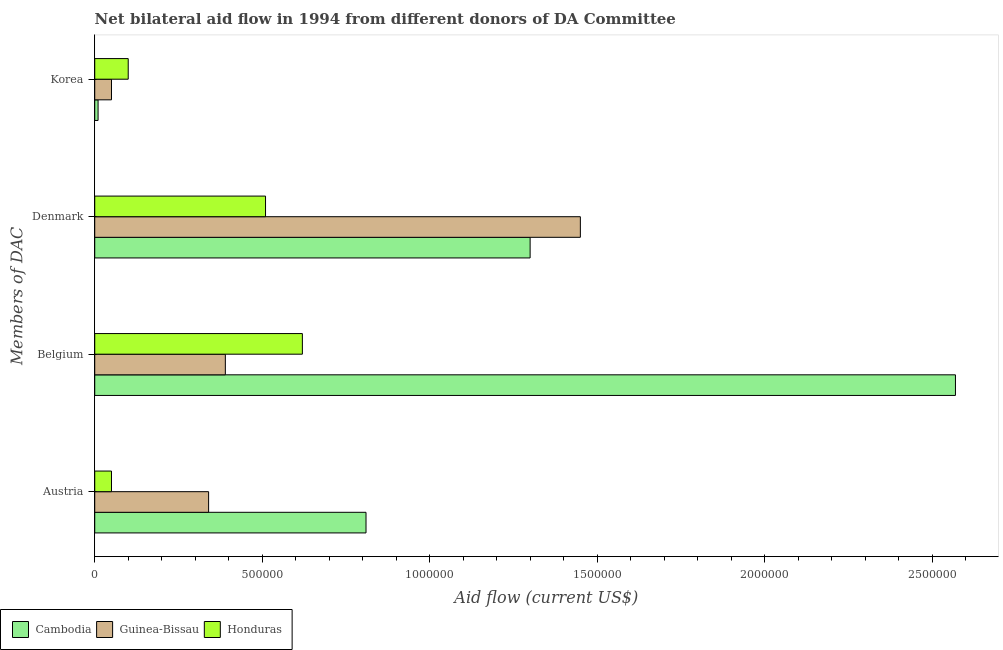How many different coloured bars are there?
Provide a succinct answer. 3. Are the number of bars per tick equal to the number of legend labels?
Provide a succinct answer. Yes. How many bars are there on the 1st tick from the top?
Make the answer very short. 3. What is the amount of aid given by belgium in Cambodia?
Provide a short and direct response. 2.57e+06. Across all countries, what is the maximum amount of aid given by belgium?
Your answer should be compact. 2.57e+06. Across all countries, what is the minimum amount of aid given by austria?
Offer a terse response. 5.00e+04. In which country was the amount of aid given by denmark maximum?
Your response must be concise. Guinea-Bissau. In which country was the amount of aid given by denmark minimum?
Your answer should be very brief. Honduras. What is the total amount of aid given by austria in the graph?
Offer a terse response. 1.20e+06. What is the difference between the amount of aid given by denmark in Cambodia and that in Honduras?
Your answer should be very brief. 7.90e+05. What is the difference between the amount of aid given by korea in Cambodia and the amount of aid given by austria in Guinea-Bissau?
Offer a very short reply. -3.30e+05. What is the average amount of aid given by korea per country?
Make the answer very short. 5.33e+04. What is the difference between the amount of aid given by belgium and amount of aid given by austria in Honduras?
Your response must be concise. 5.70e+05. In how many countries, is the amount of aid given by denmark greater than 1300000 US$?
Offer a very short reply. 1. What is the difference between the highest and the lowest amount of aid given by austria?
Keep it short and to the point. 7.60e+05. In how many countries, is the amount of aid given by korea greater than the average amount of aid given by korea taken over all countries?
Offer a terse response. 1. Is the sum of the amount of aid given by belgium in Honduras and Cambodia greater than the maximum amount of aid given by austria across all countries?
Offer a very short reply. Yes. Is it the case that in every country, the sum of the amount of aid given by belgium and amount of aid given by austria is greater than the sum of amount of aid given by denmark and amount of aid given by korea?
Keep it short and to the point. No. What does the 2nd bar from the top in Austria represents?
Provide a succinct answer. Guinea-Bissau. What does the 1st bar from the bottom in Belgium represents?
Make the answer very short. Cambodia. Are all the bars in the graph horizontal?
Keep it short and to the point. Yes. How many countries are there in the graph?
Offer a terse response. 3. Are the values on the major ticks of X-axis written in scientific E-notation?
Keep it short and to the point. No. Does the graph contain grids?
Offer a terse response. No. How many legend labels are there?
Your answer should be very brief. 3. How are the legend labels stacked?
Offer a very short reply. Horizontal. What is the title of the graph?
Give a very brief answer. Net bilateral aid flow in 1994 from different donors of DA Committee. What is the label or title of the Y-axis?
Give a very brief answer. Members of DAC. What is the Aid flow (current US$) in Cambodia in Austria?
Offer a very short reply. 8.10e+05. What is the Aid flow (current US$) of Cambodia in Belgium?
Make the answer very short. 2.57e+06. What is the Aid flow (current US$) in Guinea-Bissau in Belgium?
Your answer should be compact. 3.90e+05. What is the Aid flow (current US$) of Honduras in Belgium?
Make the answer very short. 6.20e+05. What is the Aid flow (current US$) in Cambodia in Denmark?
Your answer should be compact. 1.30e+06. What is the Aid flow (current US$) of Guinea-Bissau in Denmark?
Offer a very short reply. 1.45e+06. What is the Aid flow (current US$) in Honduras in Denmark?
Offer a very short reply. 5.10e+05. What is the Aid flow (current US$) of Cambodia in Korea?
Your answer should be compact. 10000. What is the Aid flow (current US$) of Guinea-Bissau in Korea?
Your response must be concise. 5.00e+04. Across all Members of DAC, what is the maximum Aid flow (current US$) of Cambodia?
Provide a succinct answer. 2.57e+06. Across all Members of DAC, what is the maximum Aid flow (current US$) of Guinea-Bissau?
Offer a very short reply. 1.45e+06. Across all Members of DAC, what is the maximum Aid flow (current US$) of Honduras?
Your response must be concise. 6.20e+05. Across all Members of DAC, what is the minimum Aid flow (current US$) in Guinea-Bissau?
Provide a short and direct response. 5.00e+04. What is the total Aid flow (current US$) in Cambodia in the graph?
Your answer should be very brief. 4.69e+06. What is the total Aid flow (current US$) of Guinea-Bissau in the graph?
Keep it short and to the point. 2.23e+06. What is the total Aid flow (current US$) of Honduras in the graph?
Offer a terse response. 1.28e+06. What is the difference between the Aid flow (current US$) in Cambodia in Austria and that in Belgium?
Provide a succinct answer. -1.76e+06. What is the difference between the Aid flow (current US$) in Honduras in Austria and that in Belgium?
Give a very brief answer. -5.70e+05. What is the difference between the Aid flow (current US$) of Cambodia in Austria and that in Denmark?
Provide a short and direct response. -4.90e+05. What is the difference between the Aid flow (current US$) in Guinea-Bissau in Austria and that in Denmark?
Offer a very short reply. -1.11e+06. What is the difference between the Aid flow (current US$) of Honduras in Austria and that in Denmark?
Give a very brief answer. -4.60e+05. What is the difference between the Aid flow (current US$) of Cambodia in Austria and that in Korea?
Keep it short and to the point. 8.00e+05. What is the difference between the Aid flow (current US$) of Guinea-Bissau in Austria and that in Korea?
Your answer should be compact. 2.90e+05. What is the difference between the Aid flow (current US$) of Honduras in Austria and that in Korea?
Give a very brief answer. -5.00e+04. What is the difference between the Aid flow (current US$) in Cambodia in Belgium and that in Denmark?
Offer a very short reply. 1.27e+06. What is the difference between the Aid flow (current US$) of Guinea-Bissau in Belgium and that in Denmark?
Your answer should be very brief. -1.06e+06. What is the difference between the Aid flow (current US$) of Honduras in Belgium and that in Denmark?
Offer a very short reply. 1.10e+05. What is the difference between the Aid flow (current US$) of Cambodia in Belgium and that in Korea?
Your answer should be very brief. 2.56e+06. What is the difference between the Aid flow (current US$) of Guinea-Bissau in Belgium and that in Korea?
Your response must be concise. 3.40e+05. What is the difference between the Aid flow (current US$) of Honduras in Belgium and that in Korea?
Your answer should be compact. 5.20e+05. What is the difference between the Aid flow (current US$) of Cambodia in Denmark and that in Korea?
Your answer should be compact. 1.29e+06. What is the difference between the Aid flow (current US$) in Guinea-Bissau in Denmark and that in Korea?
Provide a succinct answer. 1.40e+06. What is the difference between the Aid flow (current US$) in Honduras in Denmark and that in Korea?
Provide a short and direct response. 4.10e+05. What is the difference between the Aid flow (current US$) in Guinea-Bissau in Austria and the Aid flow (current US$) in Honduras in Belgium?
Give a very brief answer. -2.80e+05. What is the difference between the Aid flow (current US$) of Cambodia in Austria and the Aid flow (current US$) of Guinea-Bissau in Denmark?
Provide a succinct answer. -6.40e+05. What is the difference between the Aid flow (current US$) in Cambodia in Austria and the Aid flow (current US$) in Honduras in Denmark?
Keep it short and to the point. 3.00e+05. What is the difference between the Aid flow (current US$) in Cambodia in Austria and the Aid flow (current US$) in Guinea-Bissau in Korea?
Offer a terse response. 7.60e+05. What is the difference between the Aid flow (current US$) in Cambodia in Austria and the Aid flow (current US$) in Honduras in Korea?
Give a very brief answer. 7.10e+05. What is the difference between the Aid flow (current US$) of Guinea-Bissau in Austria and the Aid flow (current US$) of Honduras in Korea?
Give a very brief answer. 2.40e+05. What is the difference between the Aid flow (current US$) in Cambodia in Belgium and the Aid flow (current US$) in Guinea-Bissau in Denmark?
Offer a very short reply. 1.12e+06. What is the difference between the Aid flow (current US$) of Cambodia in Belgium and the Aid flow (current US$) of Honduras in Denmark?
Offer a very short reply. 2.06e+06. What is the difference between the Aid flow (current US$) of Cambodia in Belgium and the Aid flow (current US$) of Guinea-Bissau in Korea?
Your answer should be compact. 2.52e+06. What is the difference between the Aid flow (current US$) in Cambodia in Belgium and the Aid flow (current US$) in Honduras in Korea?
Offer a terse response. 2.47e+06. What is the difference between the Aid flow (current US$) of Guinea-Bissau in Belgium and the Aid flow (current US$) of Honduras in Korea?
Ensure brevity in your answer.  2.90e+05. What is the difference between the Aid flow (current US$) in Cambodia in Denmark and the Aid flow (current US$) in Guinea-Bissau in Korea?
Keep it short and to the point. 1.25e+06. What is the difference between the Aid flow (current US$) of Cambodia in Denmark and the Aid flow (current US$) of Honduras in Korea?
Ensure brevity in your answer.  1.20e+06. What is the difference between the Aid flow (current US$) in Guinea-Bissau in Denmark and the Aid flow (current US$) in Honduras in Korea?
Provide a succinct answer. 1.35e+06. What is the average Aid flow (current US$) in Cambodia per Members of DAC?
Your answer should be very brief. 1.17e+06. What is the average Aid flow (current US$) of Guinea-Bissau per Members of DAC?
Provide a succinct answer. 5.58e+05. What is the average Aid flow (current US$) of Honduras per Members of DAC?
Provide a succinct answer. 3.20e+05. What is the difference between the Aid flow (current US$) of Cambodia and Aid flow (current US$) of Honduras in Austria?
Make the answer very short. 7.60e+05. What is the difference between the Aid flow (current US$) in Guinea-Bissau and Aid flow (current US$) in Honduras in Austria?
Offer a very short reply. 2.90e+05. What is the difference between the Aid flow (current US$) of Cambodia and Aid flow (current US$) of Guinea-Bissau in Belgium?
Your response must be concise. 2.18e+06. What is the difference between the Aid flow (current US$) of Cambodia and Aid flow (current US$) of Honduras in Belgium?
Give a very brief answer. 1.95e+06. What is the difference between the Aid flow (current US$) in Cambodia and Aid flow (current US$) in Guinea-Bissau in Denmark?
Make the answer very short. -1.50e+05. What is the difference between the Aid flow (current US$) of Cambodia and Aid flow (current US$) of Honduras in Denmark?
Provide a succinct answer. 7.90e+05. What is the difference between the Aid flow (current US$) of Guinea-Bissau and Aid flow (current US$) of Honduras in Denmark?
Give a very brief answer. 9.40e+05. What is the ratio of the Aid flow (current US$) in Cambodia in Austria to that in Belgium?
Your answer should be very brief. 0.32. What is the ratio of the Aid flow (current US$) in Guinea-Bissau in Austria to that in Belgium?
Provide a short and direct response. 0.87. What is the ratio of the Aid flow (current US$) of Honduras in Austria to that in Belgium?
Keep it short and to the point. 0.08. What is the ratio of the Aid flow (current US$) of Cambodia in Austria to that in Denmark?
Keep it short and to the point. 0.62. What is the ratio of the Aid flow (current US$) of Guinea-Bissau in Austria to that in Denmark?
Keep it short and to the point. 0.23. What is the ratio of the Aid flow (current US$) in Honduras in Austria to that in Denmark?
Provide a short and direct response. 0.1. What is the ratio of the Aid flow (current US$) of Cambodia in Austria to that in Korea?
Ensure brevity in your answer.  81. What is the ratio of the Aid flow (current US$) in Guinea-Bissau in Austria to that in Korea?
Offer a very short reply. 6.8. What is the ratio of the Aid flow (current US$) in Cambodia in Belgium to that in Denmark?
Provide a short and direct response. 1.98. What is the ratio of the Aid flow (current US$) in Guinea-Bissau in Belgium to that in Denmark?
Provide a succinct answer. 0.27. What is the ratio of the Aid flow (current US$) in Honduras in Belgium to that in Denmark?
Make the answer very short. 1.22. What is the ratio of the Aid flow (current US$) in Cambodia in Belgium to that in Korea?
Offer a very short reply. 257. What is the ratio of the Aid flow (current US$) of Cambodia in Denmark to that in Korea?
Your answer should be very brief. 130. What is the ratio of the Aid flow (current US$) in Guinea-Bissau in Denmark to that in Korea?
Offer a terse response. 29. What is the difference between the highest and the second highest Aid flow (current US$) in Cambodia?
Give a very brief answer. 1.27e+06. What is the difference between the highest and the second highest Aid flow (current US$) of Guinea-Bissau?
Offer a very short reply. 1.06e+06. What is the difference between the highest and the second highest Aid flow (current US$) of Honduras?
Provide a succinct answer. 1.10e+05. What is the difference between the highest and the lowest Aid flow (current US$) in Cambodia?
Keep it short and to the point. 2.56e+06. What is the difference between the highest and the lowest Aid flow (current US$) in Guinea-Bissau?
Offer a terse response. 1.40e+06. What is the difference between the highest and the lowest Aid flow (current US$) of Honduras?
Keep it short and to the point. 5.70e+05. 